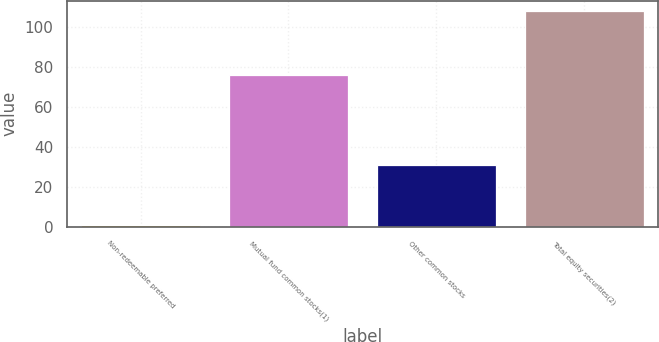<chart> <loc_0><loc_0><loc_500><loc_500><bar_chart><fcel>Non-redeemable preferred<fcel>Mutual fund common stocks(1)<fcel>Other common stocks<fcel>Total equity securities(2)<nl><fcel>1<fcel>76<fcel>31<fcel>108<nl></chart> 